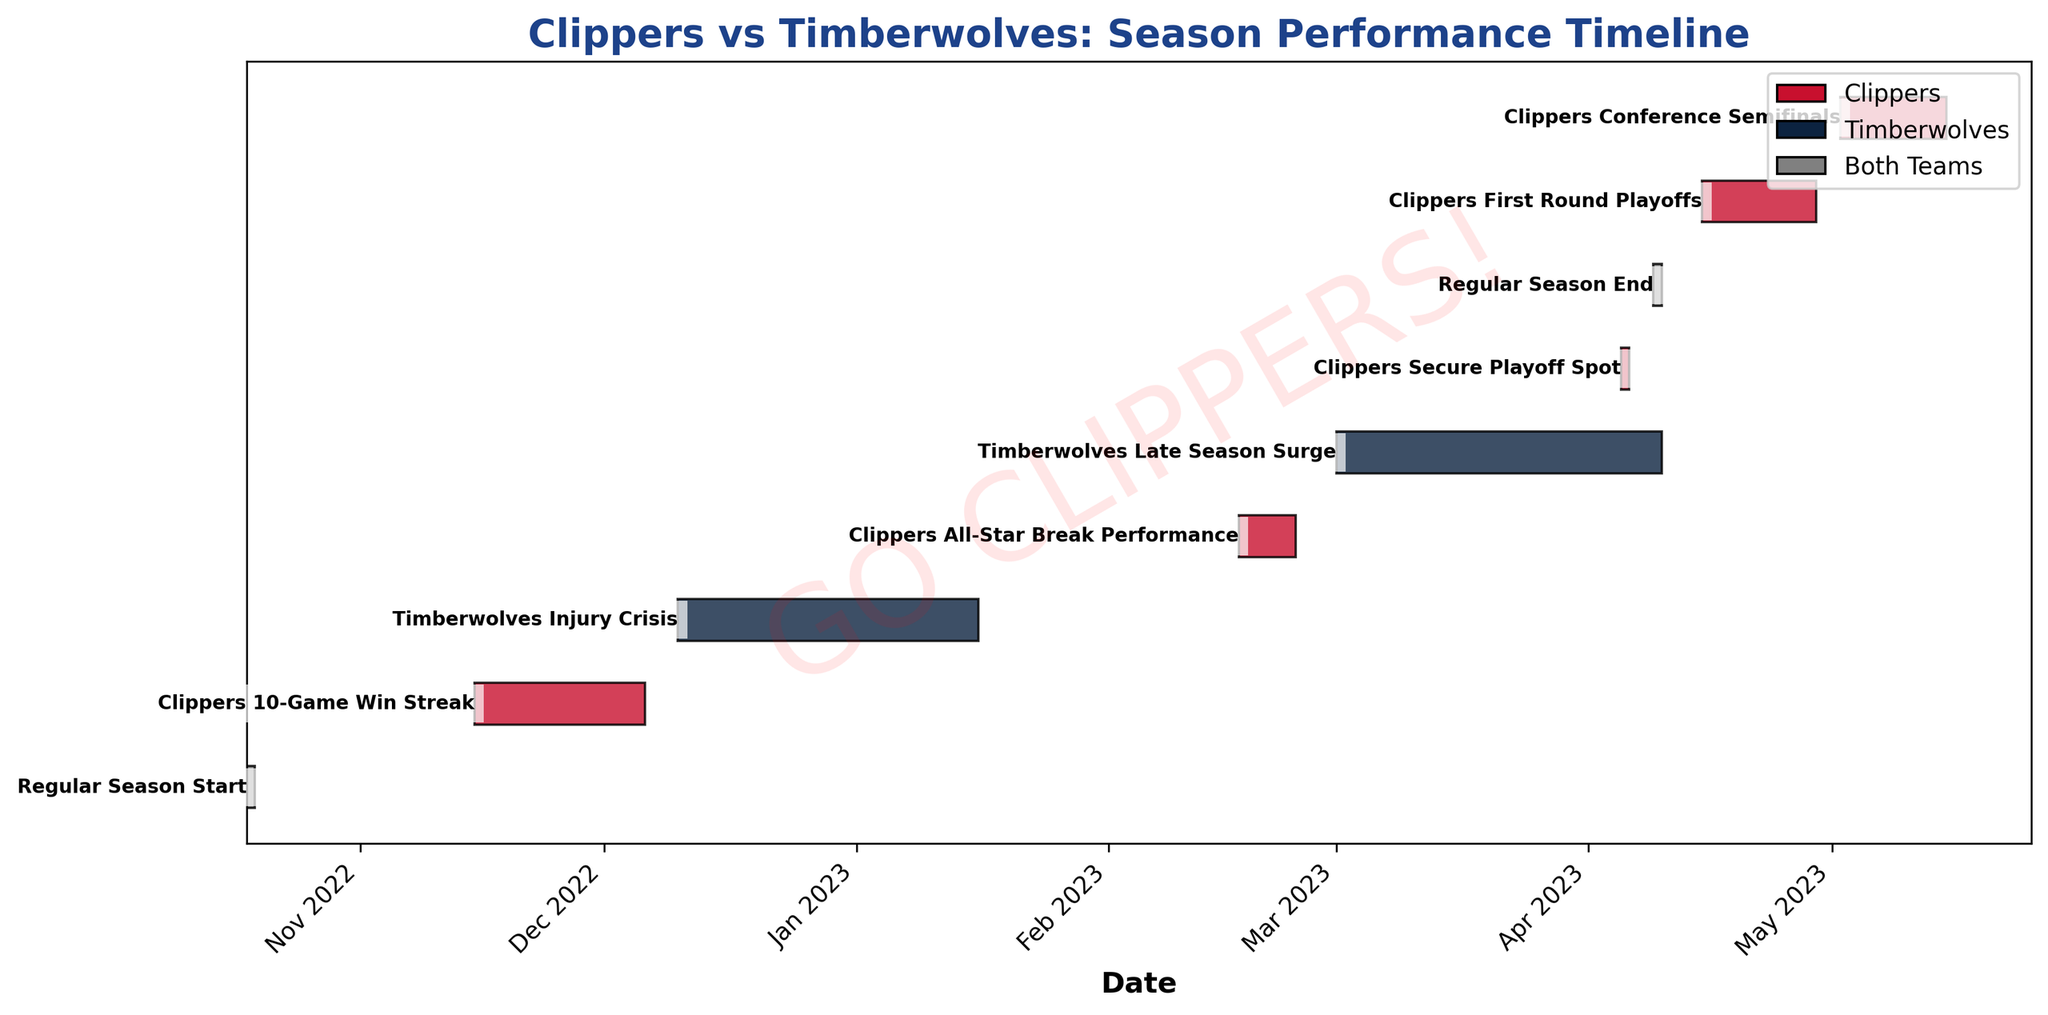Which team had a 10-game win streak? The Gantt Chart labeled "Clippers 10-Game Win Streak" indicates the win streak belongs to the Clippers.
Answer: Clippers When did the regular season start? The Gantt Chart labeled "Regular Season Start" shows the start date as 2022-10-18.
Answer: 2022-10-18 How long did the Timberwolves' injury crisis last? The Gantt Chart labeled "Timberwolves Injury Crisis" spans from 2022-12-10 to 2023-01-15. Subtracting these dates gives the duration.
Answer: 37 days Which period is marked by both teams in the chart? The Gantt Chart indicates both "Regular Season Start" and "Regular Season End" are marked by both teams.
Answer: Regular Season Start and Regular Season End What event took place during the All-Star break? The Gantt Chart labeled "Clippers All-Star Break Performance" spans from 2023-02-17 to 2023-02-23.
Answer: Clippers All-Star Break Performance Which team showed a late-season surge and when did it happen? The Gantt Chart labeled "Timberwolves Late Season Surge" indicates the team and the period as 2023-03-01 to 2023-04-09.
Answer: Timberwolves, 2023-03-01 to 2023-04-09 What was the first event marked for the Clippers in the timeline? The Gantt Chart shows "Clippers 10-Game Win Streak" as the earliest event for the Clippers starting on 2022-11-15.
Answer: Clippers 10-Game Win Streak Which team secured their playoff spot first, and what is the date? The Gantt Chart labeled "Clippers Secure Playoff Spot" shows the Clippers secured their spot on 2023-04-05. Only Clippers are mentioned concerning playoff spot securing in the chart.
Answer: Clippers, 2023-04-05 Compare the duration of "Timberwolves Late Season Surge" with "Clippers Conference Semifinals." Which one is longer? "Timberwolves Late Season Surge" spans from 2023-03-01 to 2023-04-09 (40 days), while "Clippers Conference Semifinals" spans from 2023-05-02 to 2023-05-14 (13 days). Duration comparison shows the Timberwolves' event is longer.
Answer: Timberwolves Late Season Surge List all Clippers' events in order of occurrence. From earliest to latest, the Clippers' events are: "Clippers 10-Game Win Streak", "Clippers All-Star Break Performance", "Clippers Secure Playoff Spot", "Clippers First Round Playoffs", "Clippers Conference Semifinals."
Answer: Clippers 10-Game Win Streak, Clippers All-Star Break Performance, Clippers Secure Playoff Spot, Clippers First Round Playoffs, Clippers Conference Semifinals 